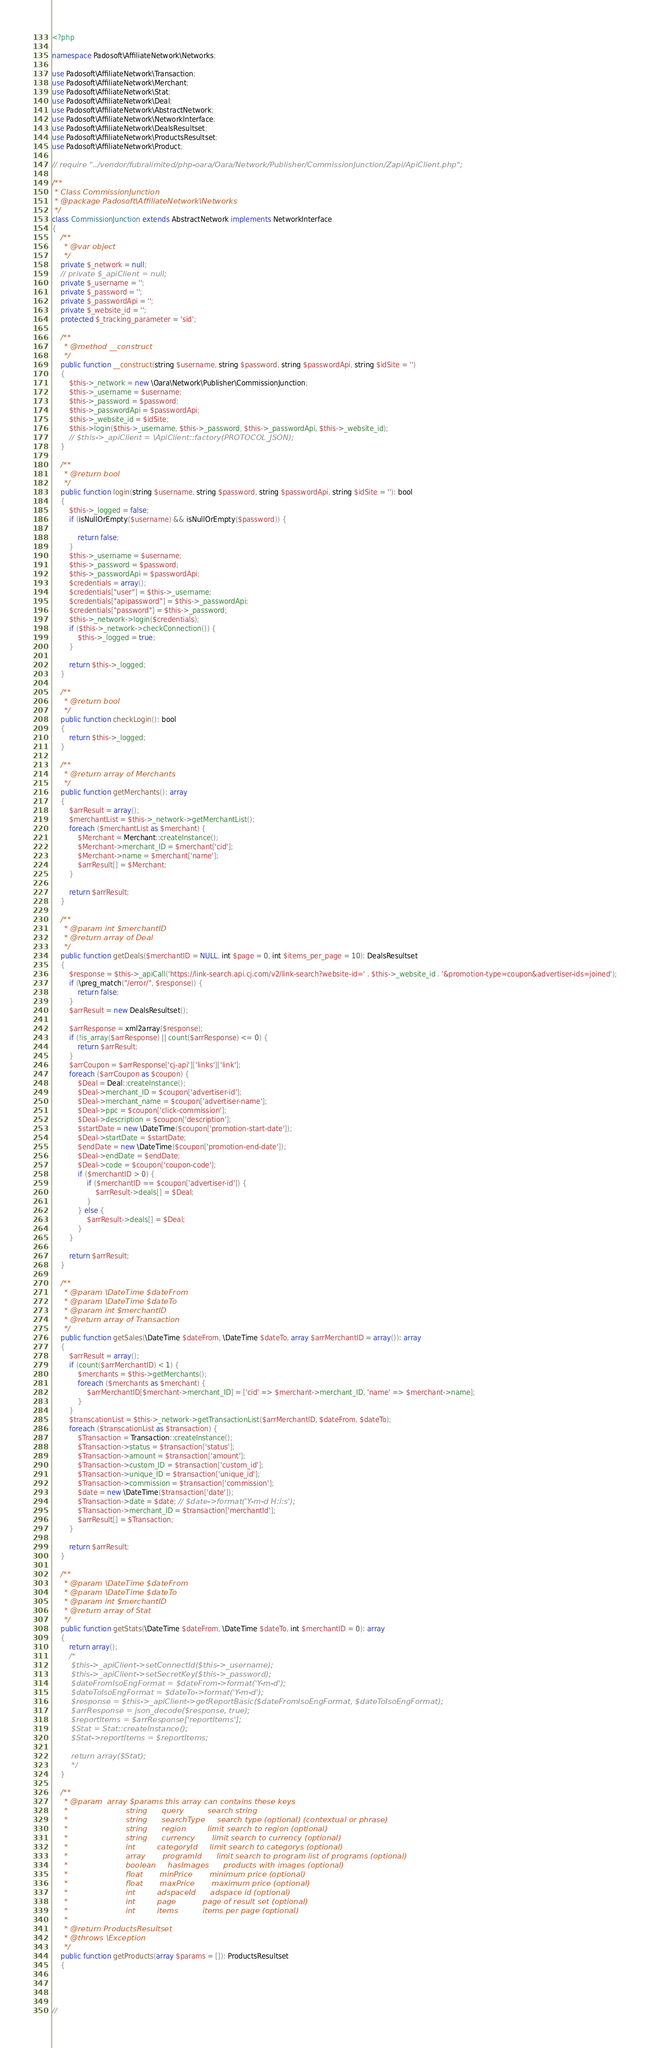Convert code to text. <code><loc_0><loc_0><loc_500><loc_500><_PHP_><?php

namespace Padosoft\AffiliateNetwork\Networks;

use Padosoft\AffiliateNetwork\Transaction;
use Padosoft\AffiliateNetwork\Merchant;
use Padosoft\AffiliateNetwork\Stat;
use Padosoft\AffiliateNetwork\Deal;
use Padosoft\AffiliateNetwork\AbstractNetwork;
use Padosoft\AffiliateNetwork\NetworkInterface;
use Padosoft\AffiliateNetwork\DealsResultset;
use Padosoft\AffiliateNetwork\ProductsResultset;
use Padosoft\AffiliateNetwork\Product;

// require "../vendor/fubralimited/php-oara/Oara/Network/Publisher/CommissionJunction/Zapi/ApiClient.php";

/**
 * Class CommissionJunction
 * @package Padosoft\AffiliateNetwork\Networks
 */
class CommissionJunction extends AbstractNetwork implements NetworkInterface
{
    /**
     * @var object
     */
    private $_network = null;
    // private $_apiClient = null;
    private $_username = '';
    private $_password = '';
    private $_passwordApi = '';
    private $_website_id = '';
    protected $_tracking_parameter = 'sid';

    /**
     * @method __construct
     */
    public function __construct(string $username, string $password, string $passwordApi, string $idSite = '')
    {
        $this->_network = new \Oara\Network\Publisher\CommissionJunction;
        $this->_username = $username;
        $this->_password = $password;
        $this->_passwordApi = $passwordApi;
        $this->_website_id = $idSite;
        $this->login($this->_username, $this->_password, $this->_passwordApi, $this->_website_id);
        // $this->_apiClient = \ApiClient::factory(PROTOCOL_JSON);
    }

    /**
     * @return bool
     */
    public function login(string $username, string $password, string $passwordApi, string $idSite = ''): bool
    {
        $this->_logged = false;
        if (isNullOrEmpty($username) && isNullOrEmpty($password)) {

            return false;
        }
        $this->_username = $username;
        $this->_password = $password;
        $this->_passwordApi = $passwordApi;
        $credentials = array();
        $credentials["user"] = $this->_username;
        $credentials["apipassword"] = $this->_passwordApi;
        $credentials["password"] = $this->_password;
        $this->_network->login($credentials);
        if ($this->_network->checkConnection()) {
            $this->_logged = true;
        }

        return $this->_logged;
    }

    /**
     * @return bool
     */
    public function checkLogin(): bool
    {
        return $this->_logged;
    }

    /**
     * @return array of Merchants
     */
    public function getMerchants(): array
    {
        $arrResult = array();
        $merchantList = $this->_network->getMerchantList();
        foreach ($merchantList as $merchant) {
            $Merchant = Merchant::createInstance();
            $Merchant->merchant_ID = $merchant['cid'];
            $Merchant->name = $merchant['name'];
            $arrResult[] = $Merchant;
        }

        return $arrResult;
    }

    /**
     * @param int $merchantID
     * @return array of Deal
     */
    public function getDeals($merchantID = NULL, int $page = 0, int $items_per_page = 10): DealsResultset
    {
        $response = $this->_apiCall('https://link-search.api.cj.com/v2/link-search?website-id=' . $this->_website_id . '&promotion-type=coupon&advertiser-ids=joined');
        if (\preg_match("/error/", $response)) {
            return false;
        }
        $arrResult = new DealsResultset();

        $arrResponse = xml2array($response);
        if (!is_array($arrResponse) || count($arrResponse) <= 0) {
            return $arrResult;
        }
        $arrCoupon = $arrResponse['cj-api']['links']['link'];
        foreach ($arrCoupon as $coupon) {
            $Deal = Deal::createInstance();
            $Deal->merchant_ID = $coupon['advertiser-id'];
            $Deal->merchant_name = $coupon['advertiser-name'];
            $Deal->ppc = $coupon['click-commission'];
            $Deal->description = $coupon['description'];
            $startDate = new \DateTime($coupon['promotion-start-date']);
            $Deal->startDate = $startDate;
            $endDate = new \DateTime($coupon['promotion-end-date']);
            $Deal->endDate = $endDate;
            $Deal->code = $coupon['coupon-code'];
            if ($merchantID > 0) {
                if ($merchantID == $coupon['advertiser-id']) {
                    $arrResult->deals[] = $Deal;
                }
            } else {
                $arrResult->deals[] = $Deal;
            }
        }

        return $arrResult;
    }

    /**
     * @param \DateTime $dateFrom
     * @param \DateTime $dateTo
     * @param int $merchantID
     * @return array of Transaction
     */
    public function getSales(\DateTime $dateFrom, \DateTime $dateTo, array $arrMerchantID = array()): array
    {
        $arrResult = array();
        if (count($arrMerchantID) < 1) {
            $merchants = $this->getMerchants();
            foreach ($merchants as $merchant) {
                $arrMerchantID[$merchant->merchant_ID] = ['cid' => $merchant->merchant_ID, 'name' => $merchant->name];
            }
        }
        $transcationList = $this->_network->getTransactionList($arrMerchantID, $dateFrom, $dateTo);
        foreach ($transcationList as $transaction) {
            $Transaction = Transaction::createInstance();
            $Transaction->status = $transaction['status'];
            $Transaction->amount = $transaction['amount'];
            $Transaction->custom_ID = $transaction['custom_id'];
            $Transaction->unique_ID = $transaction['unique_id'];
            $Transaction->commission = $transaction['commission'];
            $date = new \DateTime($transaction['date']);
            $Transaction->date = $date; // $date->format('Y-m-d H:i:s');
            $Transaction->merchant_ID = $transaction['merchantId'];
            $arrResult[] = $Transaction;
        }

        return $arrResult;
    }

    /**
     * @param \DateTime $dateFrom
     * @param \DateTime $dateTo
     * @param int $merchantID
     * @return array of Stat
     */
    public function getStats(\DateTime $dateFrom, \DateTime $dateTo, int $merchantID = 0): array
    {
        return array();
        /*
        $this->_apiClient->setConnectId($this->_username);
        $this->_apiClient->setSecretKey($this->_password);
        $dateFromIsoEngFormat = $dateFrom->format('Y-m-d');
        $dateToIsoEngFormat = $dateTo->format('Y-m-d');
        $response = $this->_apiClient->getReportBasic($dateFromIsoEngFormat, $dateToIsoEngFormat);
        $arrResponse = json_decode($response, true);
        $reportItems = $arrResponse['reportItems'];
        $Stat = Stat::createInstance();
        $Stat->reportItems = $reportItems;

        return array($Stat);
        */
    }

    /**
     * @param  array $params this array can contains these keys
     *                        string      query          search string
     *                        string      searchType     search type (optional) (contextual or phrase)
     *                        string      region         limit search to region (optional)
     *                        string      currency       limit search to currency (optional)
     *                        int         categoryId     limit search to categorys (optional)
     *                        array       programId      limit search to program list of programs (optional)
     *                        boolean     hasImages      products with images (optional)
     *                        float       minPrice       minimum price (optional)
     *                        float       maxPrice       maximum price (optional)
     *                        int         adspaceId      adspace id (optional)
     *                        int         page           page of result set (optional)
     *                        int         items          items per page (optional)
     *
     * @return ProductsResultset
     * @throws \Exception
     */
    public function getProducts(array $params = []): ProductsResultset
    {




//</code> 